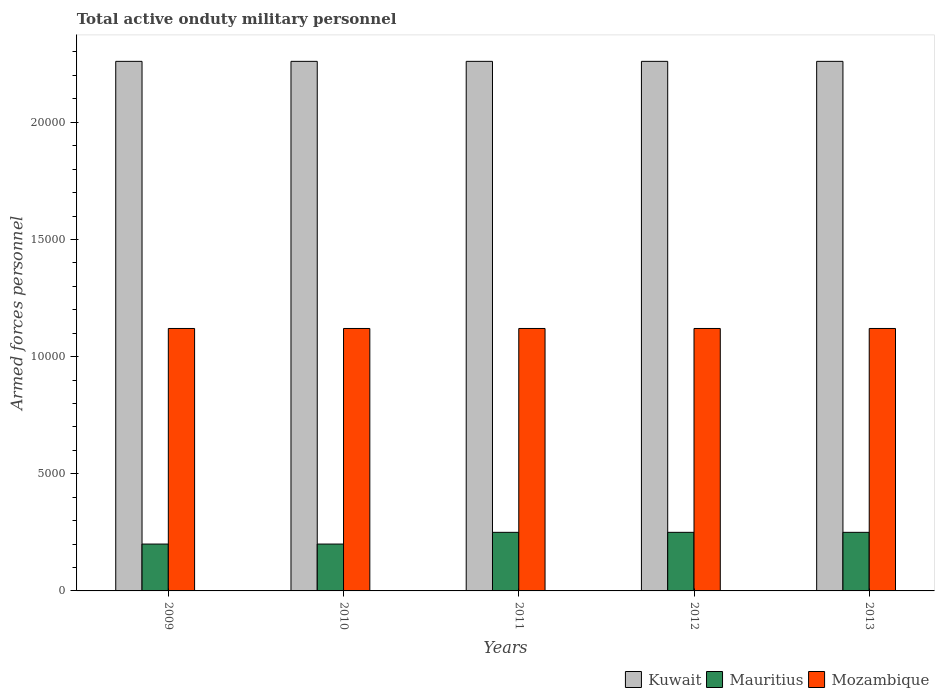How many different coloured bars are there?
Your answer should be compact. 3. How many groups of bars are there?
Your answer should be compact. 5. Are the number of bars per tick equal to the number of legend labels?
Provide a short and direct response. Yes. How many bars are there on the 1st tick from the right?
Your answer should be very brief. 3. What is the label of the 5th group of bars from the left?
Provide a succinct answer. 2013. What is the number of armed forces personnel in Mozambique in 2011?
Your answer should be very brief. 1.12e+04. Across all years, what is the maximum number of armed forces personnel in Mozambique?
Offer a very short reply. 1.12e+04. Across all years, what is the minimum number of armed forces personnel in Mozambique?
Provide a succinct answer. 1.12e+04. In which year was the number of armed forces personnel in Mauritius maximum?
Ensure brevity in your answer.  2011. What is the total number of armed forces personnel in Mauritius in the graph?
Provide a short and direct response. 1.15e+04. What is the difference between the number of armed forces personnel in Kuwait in 2010 and the number of armed forces personnel in Mauritius in 2013?
Your response must be concise. 2.01e+04. What is the average number of armed forces personnel in Mozambique per year?
Ensure brevity in your answer.  1.12e+04. In the year 2011, what is the difference between the number of armed forces personnel in Mauritius and number of armed forces personnel in Mozambique?
Offer a very short reply. -8700. In how many years, is the number of armed forces personnel in Kuwait greater than 15000?
Make the answer very short. 5. What is the ratio of the number of armed forces personnel in Mauritius in 2010 to that in 2013?
Your answer should be compact. 0.8. Is the number of armed forces personnel in Mauritius in 2011 less than that in 2013?
Give a very brief answer. No. What is the difference between the highest and the lowest number of armed forces personnel in Kuwait?
Ensure brevity in your answer.  0. Is the sum of the number of armed forces personnel in Mauritius in 2009 and 2013 greater than the maximum number of armed forces personnel in Mozambique across all years?
Your answer should be compact. No. What does the 1st bar from the left in 2009 represents?
Give a very brief answer. Kuwait. What does the 1st bar from the right in 2010 represents?
Provide a short and direct response. Mozambique. Are all the bars in the graph horizontal?
Offer a very short reply. No. Does the graph contain any zero values?
Your response must be concise. No. How are the legend labels stacked?
Your response must be concise. Horizontal. What is the title of the graph?
Offer a terse response. Total active onduty military personnel. What is the label or title of the Y-axis?
Ensure brevity in your answer.  Armed forces personnel. What is the Armed forces personnel in Kuwait in 2009?
Give a very brief answer. 2.26e+04. What is the Armed forces personnel in Mauritius in 2009?
Your answer should be very brief. 2000. What is the Armed forces personnel of Mozambique in 2009?
Provide a succinct answer. 1.12e+04. What is the Armed forces personnel of Kuwait in 2010?
Offer a very short reply. 2.26e+04. What is the Armed forces personnel in Mauritius in 2010?
Provide a short and direct response. 2000. What is the Armed forces personnel in Mozambique in 2010?
Ensure brevity in your answer.  1.12e+04. What is the Armed forces personnel of Kuwait in 2011?
Your response must be concise. 2.26e+04. What is the Armed forces personnel in Mauritius in 2011?
Your response must be concise. 2500. What is the Armed forces personnel of Mozambique in 2011?
Ensure brevity in your answer.  1.12e+04. What is the Armed forces personnel of Kuwait in 2012?
Offer a very short reply. 2.26e+04. What is the Armed forces personnel of Mauritius in 2012?
Ensure brevity in your answer.  2500. What is the Armed forces personnel in Mozambique in 2012?
Make the answer very short. 1.12e+04. What is the Armed forces personnel in Kuwait in 2013?
Keep it short and to the point. 2.26e+04. What is the Armed forces personnel in Mauritius in 2013?
Provide a succinct answer. 2500. What is the Armed forces personnel in Mozambique in 2013?
Keep it short and to the point. 1.12e+04. Across all years, what is the maximum Armed forces personnel in Kuwait?
Your answer should be very brief. 2.26e+04. Across all years, what is the maximum Armed forces personnel in Mauritius?
Offer a very short reply. 2500. Across all years, what is the maximum Armed forces personnel of Mozambique?
Offer a very short reply. 1.12e+04. Across all years, what is the minimum Armed forces personnel of Kuwait?
Ensure brevity in your answer.  2.26e+04. Across all years, what is the minimum Armed forces personnel of Mozambique?
Give a very brief answer. 1.12e+04. What is the total Armed forces personnel in Kuwait in the graph?
Ensure brevity in your answer.  1.13e+05. What is the total Armed forces personnel in Mauritius in the graph?
Provide a short and direct response. 1.15e+04. What is the total Armed forces personnel in Mozambique in the graph?
Your answer should be compact. 5.60e+04. What is the difference between the Armed forces personnel of Mozambique in 2009 and that in 2010?
Your answer should be very brief. 0. What is the difference between the Armed forces personnel in Kuwait in 2009 and that in 2011?
Your response must be concise. 0. What is the difference between the Armed forces personnel in Mauritius in 2009 and that in 2011?
Offer a terse response. -500. What is the difference between the Armed forces personnel of Mauritius in 2009 and that in 2012?
Ensure brevity in your answer.  -500. What is the difference between the Armed forces personnel in Mozambique in 2009 and that in 2012?
Your answer should be compact. 0. What is the difference between the Armed forces personnel in Kuwait in 2009 and that in 2013?
Your answer should be very brief. 0. What is the difference between the Armed forces personnel in Mauritius in 2009 and that in 2013?
Your answer should be compact. -500. What is the difference between the Armed forces personnel in Mauritius in 2010 and that in 2011?
Keep it short and to the point. -500. What is the difference between the Armed forces personnel of Kuwait in 2010 and that in 2012?
Offer a terse response. 0. What is the difference between the Armed forces personnel in Mauritius in 2010 and that in 2012?
Give a very brief answer. -500. What is the difference between the Armed forces personnel of Mozambique in 2010 and that in 2012?
Your response must be concise. 0. What is the difference between the Armed forces personnel in Mauritius in 2010 and that in 2013?
Your answer should be compact. -500. What is the difference between the Armed forces personnel in Mozambique in 2010 and that in 2013?
Give a very brief answer. 0. What is the difference between the Armed forces personnel of Kuwait in 2011 and that in 2012?
Make the answer very short. 0. What is the difference between the Armed forces personnel of Mauritius in 2011 and that in 2012?
Your response must be concise. 0. What is the difference between the Armed forces personnel of Kuwait in 2011 and that in 2013?
Offer a very short reply. 0. What is the difference between the Armed forces personnel in Mozambique in 2011 and that in 2013?
Offer a very short reply. 0. What is the difference between the Armed forces personnel in Kuwait in 2012 and that in 2013?
Provide a short and direct response. 0. What is the difference between the Armed forces personnel in Mozambique in 2012 and that in 2013?
Ensure brevity in your answer.  0. What is the difference between the Armed forces personnel in Kuwait in 2009 and the Armed forces personnel in Mauritius in 2010?
Ensure brevity in your answer.  2.06e+04. What is the difference between the Armed forces personnel of Kuwait in 2009 and the Armed forces personnel of Mozambique in 2010?
Give a very brief answer. 1.14e+04. What is the difference between the Armed forces personnel in Mauritius in 2009 and the Armed forces personnel in Mozambique in 2010?
Make the answer very short. -9200. What is the difference between the Armed forces personnel of Kuwait in 2009 and the Armed forces personnel of Mauritius in 2011?
Offer a very short reply. 2.01e+04. What is the difference between the Armed forces personnel in Kuwait in 2009 and the Armed forces personnel in Mozambique in 2011?
Make the answer very short. 1.14e+04. What is the difference between the Armed forces personnel of Mauritius in 2009 and the Armed forces personnel of Mozambique in 2011?
Your response must be concise. -9200. What is the difference between the Armed forces personnel of Kuwait in 2009 and the Armed forces personnel of Mauritius in 2012?
Your answer should be very brief. 2.01e+04. What is the difference between the Armed forces personnel in Kuwait in 2009 and the Armed forces personnel in Mozambique in 2012?
Provide a short and direct response. 1.14e+04. What is the difference between the Armed forces personnel of Mauritius in 2009 and the Armed forces personnel of Mozambique in 2012?
Provide a short and direct response. -9200. What is the difference between the Armed forces personnel of Kuwait in 2009 and the Armed forces personnel of Mauritius in 2013?
Make the answer very short. 2.01e+04. What is the difference between the Armed forces personnel in Kuwait in 2009 and the Armed forces personnel in Mozambique in 2013?
Make the answer very short. 1.14e+04. What is the difference between the Armed forces personnel in Mauritius in 2009 and the Armed forces personnel in Mozambique in 2013?
Offer a terse response. -9200. What is the difference between the Armed forces personnel in Kuwait in 2010 and the Armed forces personnel in Mauritius in 2011?
Keep it short and to the point. 2.01e+04. What is the difference between the Armed forces personnel in Kuwait in 2010 and the Armed forces personnel in Mozambique in 2011?
Ensure brevity in your answer.  1.14e+04. What is the difference between the Armed forces personnel of Mauritius in 2010 and the Armed forces personnel of Mozambique in 2011?
Offer a terse response. -9200. What is the difference between the Armed forces personnel in Kuwait in 2010 and the Armed forces personnel in Mauritius in 2012?
Ensure brevity in your answer.  2.01e+04. What is the difference between the Armed forces personnel of Kuwait in 2010 and the Armed forces personnel of Mozambique in 2012?
Make the answer very short. 1.14e+04. What is the difference between the Armed forces personnel of Mauritius in 2010 and the Armed forces personnel of Mozambique in 2012?
Your answer should be compact. -9200. What is the difference between the Armed forces personnel in Kuwait in 2010 and the Armed forces personnel in Mauritius in 2013?
Your answer should be very brief. 2.01e+04. What is the difference between the Armed forces personnel of Kuwait in 2010 and the Armed forces personnel of Mozambique in 2013?
Offer a terse response. 1.14e+04. What is the difference between the Armed forces personnel in Mauritius in 2010 and the Armed forces personnel in Mozambique in 2013?
Make the answer very short. -9200. What is the difference between the Armed forces personnel of Kuwait in 2011 and the Armed forces personnel of Mauritius in 2012?
Keep it short and to the point. 2.01e+04. What is the difference between the Armed forces personnel in Kuwait in 2011 and the Armed forces personnel in Mozambique in 2012?
Provide a succinct answer. 1.14e+04. What is the difference between the Armed forces personnel in Mauritius in 2011 and the Armed forces personnel in Mozambique in 2012?
Keep it short and to the point. -8700. What is the difference between the Armed forces personnel in Kuwait in 2011 and the Armed forces personnel in Mauritius in 2013?
Provide a succinct answer. 2.01e+04. What is the difference between the Armed forces personnel of Kuwait in 2011 and the Armed forces personnel of Mozambique in 2013?
Your answer should be very brief. 1.14e+04. What is the difference between the Armed forces personnel of Mauritius in 2011 and the Armed forces personnel of Mozambique in 2013?
Your answer should be very brief. -8700. What is the difference between the Armed forces personnel in Kuwait in 2012 and the Armed forces personnel in Mauritius in 2013?
Provide a short and direct response. 2.01e+04. What is the difference between the Armed forces personnel in Kuwait in 2012 and the Armed forces personnel in Mozambique in 2013?
Make the answer very short. 1.14e+04. What is the difference between the Armed forces personnel of Mauritius in 2012 and the Armed forces personnel of Mozambique in 2013?
Offer a terse response. -8700. What is the average Armed forces personnel of Kuwait per year?
Your answer should be compact. 2.26e+04. What is the average Armed forces personnel of Mauritius per year?
Ensure brevity in your answer.  2300. What is the average Armed forces personnel in Mozambique per year?
Ensure brevity in your answer.  1.12e+04. In the year 2009, what is the difference between the Armed forces personnel of Kuwait and Armed forces personnel of Mauritius?
Ensure brevity in your answer.  2.06e+04. In the year 2009, what is the difference between the Armed forces personnel of Kuwait and Armed forces personnel of Mozambique?
Make the answer very short. 1.14e+04. In the year 2009, what is the difference between the Armed forces personnel in Mauritius and Armed forces personnel in Mozambique?
Your answer should be very brief. -9200. In the year 2010, what is the difference between the Armed forces personnel in Kuwait and Armed forces personnel in Mauritius?
Offer a very short reply. 2.06e+04. In the year 2010, what is the difference between the Armed forces personnel in Kuwait and Armed forces personnel in Mozambique?
Offer a terse response. 1.14e+04. In the year 2010, what is the difference between the Armed forces personnel in Mauritius and Armed forces personnel in Mozambique?
Offer a terse response. -9200. In the year 2011, what is the difference between the Armed forces personnel in Kuwait and Armed forces personnel in Mauritius?
Give a very brief answer. 2.01e+04. In the year 2011, what is the difference between the Armed forces personnel of Kuwait and Armed forces personnel of Mozambique?
Keep it short and to the point. 1.14e+04. In the year 2011, what is the difference between the Armed forces personnel in Mauritius and Armed forces personnel in Mozambique?
Provide a short and direct response. -8700. In the year 2012, what is the difference between the Armed forces personnel of Kuwait and Armed forces personnel of Mauritius?
Your answer should be very brief. 2.01e+04. In the year 2012, what is the difference between the Armed forces personnel of Kuwait and Armed forces personnel of Mozambique?
Your answer should be compact. 1.14e+04. In the year 2012, what is the difference between the Armed forces personnel of Mauritius and Armed forces personnel of Mozambique?
Provide a succinct answer. -8700. In the year 2013, what is the difference between the Armed forces personnel of Kuwait and Armed forces personnel of Mauritius?
Keep it short and to the point. 2.01e+04. In the year 2013, what is the difference between the Armed forces personnel in Kuwait and Armed forces personnel in Mozambique?
Keep it short and to the point. 1.14e+04. In the year 2013, what is the difference between the Armed forces personnel of Mauritius and Armed forces personnel of Mozambique?
Your response must be concise. -8700. What is the ratio of the Armed forces personnel in Mauritius in 2009 to that in 2010?
Your answer should be compact. 1. What is the ratio of the Armed forces personnel in Kuwait in 2009 to that in 2011?
Offer a terse response. 1. What is the ratio of the Armed forces personnel in Mauritius in 2009 to that in 2011?
Offer a terse response. 0.8. What is the ratio of the Armed forces personnel of Mozambique in 2009 to that in 2011?
Offer a terse response. 1. What is the ratio of the Armed forces personnel in Mauritius in 2009 to that in 2012?
Provide a short and direct response. 0.8. What is the ratio of the Armed forces personnel of Mozambique in 2009 to that in 2012?
Make the answer very short. 1. What is the ratio of the Armed forces personnel of Kuwait in 2009 to that in 2013?
Offer a terse response. 1. What is the ratio of the Armed forces personnel of Mozambique in 2009 to that in 2013?
Keep it short and to the point. 1. What is the ratio of the Armed forces personnel in Kuwait in 2010 to that in 2011?
Your response must be concise. 1. What is the ratio of the Armed forces personnel in Mozambique in 2010 to that in 2011?
Ensure brevity in your answer.  1. What is the ratio of the Armed forces personnel in Kuwait in 2010 to that in 2012?
Your answer should be very brief. 1. What is the ratio of the Armed forces personnel of Mozambique in 2010 to that in 2013?
Provide a short and direct response. 1. What is the ratio of the Armed forces personnel in Mauritius in 2011 to that in 2012?
Make the answer very short. 1. What is the ratio of the Armed forces personnel of Kuwait in 2011 to that in 2013?
Your answer should be compact. 1. What is the ratio of the Armed forces personnel of Kuwait in 2012 to that in 2013?
Provide a short and direct response. 1. What is the ratio of the Armed forces personnel in Mauritius in 2012 to that in 2013?
Give a very brief answer. 1. What is the difference between the highest and the second highest Armed forces personnel in Mozambique?
Your response must be concise. 0. What is the difference between the highest and the lowest Armed forces personnel in Mauritius?
Provide a succinct answer. 500. 